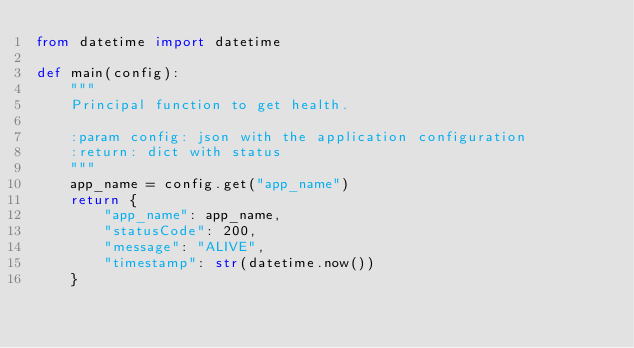Convert code to text. <code><loc_0><loc_0><loc_500><loc_500><_Python_>from datetime import datetime

def main(config):
    """
    Principal function to get health.

    :param config: json with the application configuration
    :return: dict with status
    """
    app_name = config.get("app_name")
    return {
        "app_name": app_name,
        "statusCode": 200,
        "message": "ALIVE",
        "timestamp": str(datetime.now())
    }
</code> 